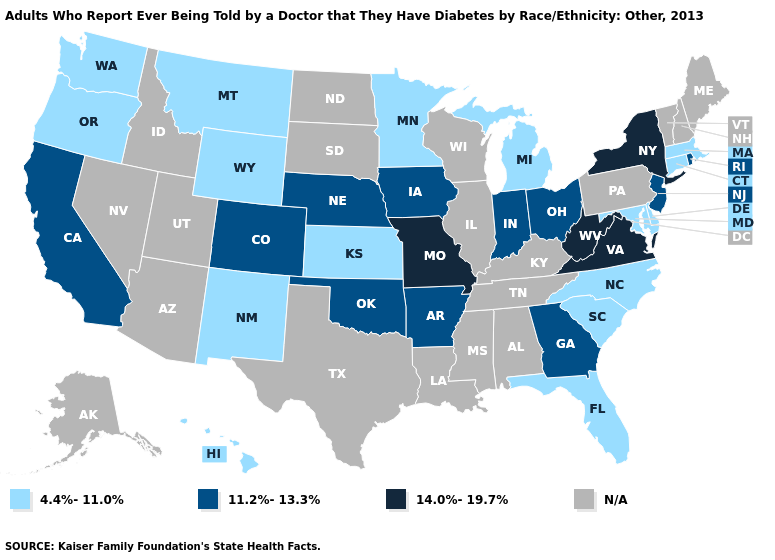What is the value of Connecticut?
Quick response, please. 4.4%-11.0%. Which states have the highest value in the USA?
Quick response, please. Missouri, New York, Virginia, West Virginia. What is the value of South Carolina?
Give a very brief answer. 4.4%-11.0%. Among the states that border Florida , which have the highest value?
Be succinct. Georgia. What is the lowest value in states that border Washington?
Give a very brief answer. 4.4%-11.0%. Name the states that have a value in the range 14.0%-19.7%?
Concise answer only. Missouri, New York, Virginia, West Virginia. Does the first symbol in the legend represent the smallest category?
Answer briefly. Yes. Name the states that have a value in the range 4.4%-11.0%?
Answer briefly. Connecticut, Delaware, Florida, Hawaii, Kansas, Maryland, Massachusetts, Michigan, Minnesota, Montana, New Mexico, North Carolina, Oregon, South Carolina, Washington, Wyoming. What is the highest value in the USA?
Answer briefly. 14.0%-19.7%. Among the states that border Wisconsin , which have the lowest value?
Be succinct. Michigan, Minnesota. Name the states that have a value in the range N/A?
Concise answer only. Alabama, Alaska, Arizona, Idaho, Illinois, Kentucky, Louisiana, Maine, Mississippi, Nevada, New Hampshire, North Dakota, Pennsylvania, South Dakota, Tennessee, Texas, Utah, Vermont, Wisconsin. Which states have the highest value in the USA?
Write a very short answer. Missouri, New York, Virginia, West Virginia. Does the first symbol in the legend represent the smallest category?
Write a very short answer. Yes. 